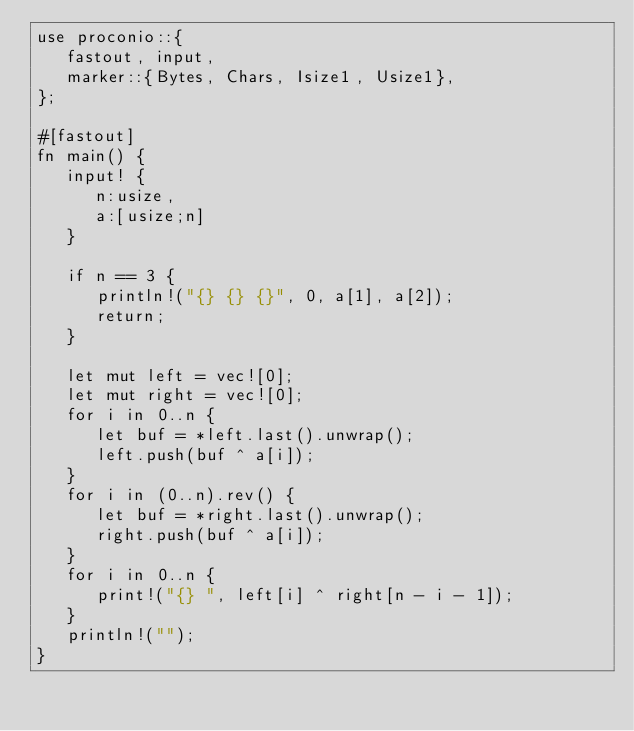<code> <loc_0><loc_0><loc_500><loc_500><_Rust_>use proconio::{
   fastout, input,
   marker::{Bytes, Chars, Isize1, Usize1},
};

#[fastout]
fn main() {
   input! {
      n:usize,
      a:[usize;n]
   }

   if n == 3 {
      println!("{} {} {}", 0, a[1], a[2]);
      return;
   }

   let mut left = vec![0];
   let mut right = vec![0];
   for i in 0..n {
      let buf = *left.last().unwrap();
      left.push(buf ^ a[i]);
   }
   for i in (0..n).rev() {
      let buf = *right.last().unwrap();
      right.push(buf ^ a[i]);
   }
   for i in 0..n {
      print!("{} ", left[i] ^ right[n - i - 1]);
   }
   println!("");
}
</code> 